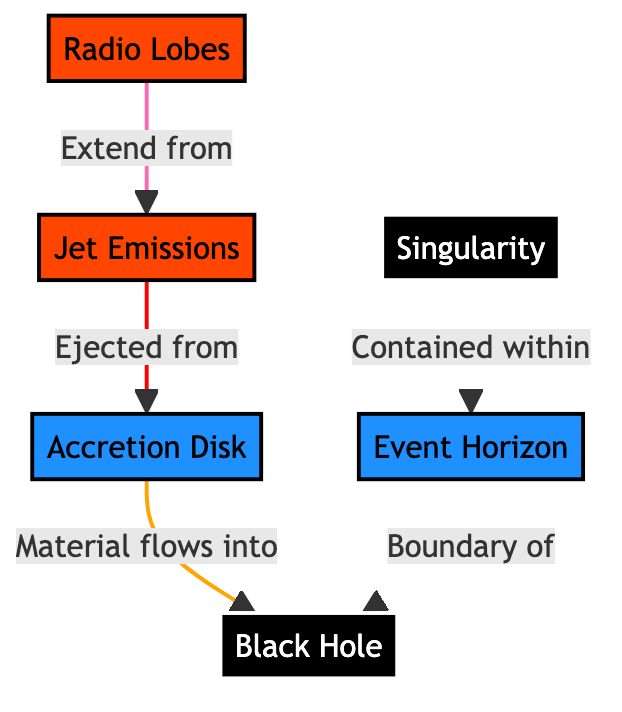What is the main subject of the diagram? The diagram's main subject is the Black Hole, which is the central focus of the rendering. There is a label clearly marking it as "Black Hole."
Answer: Black Hole What does the Event Horizon represent? The Event Horizon in the diagram is indicated as the boundary of the Black Hole. It represents the point beyond which nothing can escape the gravitational pull of the Black Hole. This is reflected in the connection labeled "Boundary of."
Answer: Boundary How many major components are depicted in the diagram? The diagram outlines four distinct components: the Black Hole, Event Horizon, Accretion Disk, and Jet Emissions. By counting these labels, we confirm there are four components total.
Answer: 4 What direction does material flow into the Black Hole? The diagram shows a directional arrow labeled "Material flows into," leading from the Accretion Disk towards the Black Hole. This indicates the flow of matter into the Black Hole.
Answer: Into What is emitted from the Accretion Disk? The connection labeled "Ejected from" indicates that Jet Emissions are produced from the Accretion Disk. This implies that the material undergoing intense gravitational forces results in emissions being released.
Answer: Jet Emissions Which component contains the Singularity? The diagram shows a direct connection indicating that the Singularity is contained within the Event Horizon, confirming that it resides inside this boundary.
Answer: Event Horizon What color represents the emissions in the diagram? The emissions, represented by the 'Jet Emissions' and 'Radio Lobes' in the diagram, are filled with a distinct orange-red color, specifically denoted as '#FF4500' in the code.
Answer: Orange-red What are the Radio Lobes connected to? The diagram indicates that Radio Lobes extend from the Jet Emissions, showcasing their direct relationship with one another. This connection is labeled "Extend from."
Answer: Jet Emissions What is the relationship between the Singularity and the Event Horizon? The diagram establishes that the Singularity is "Contained within" the Event Horizon, making it clear that the singularity lies inside this boundary that marks the point of no return.
Answer: Contained within 